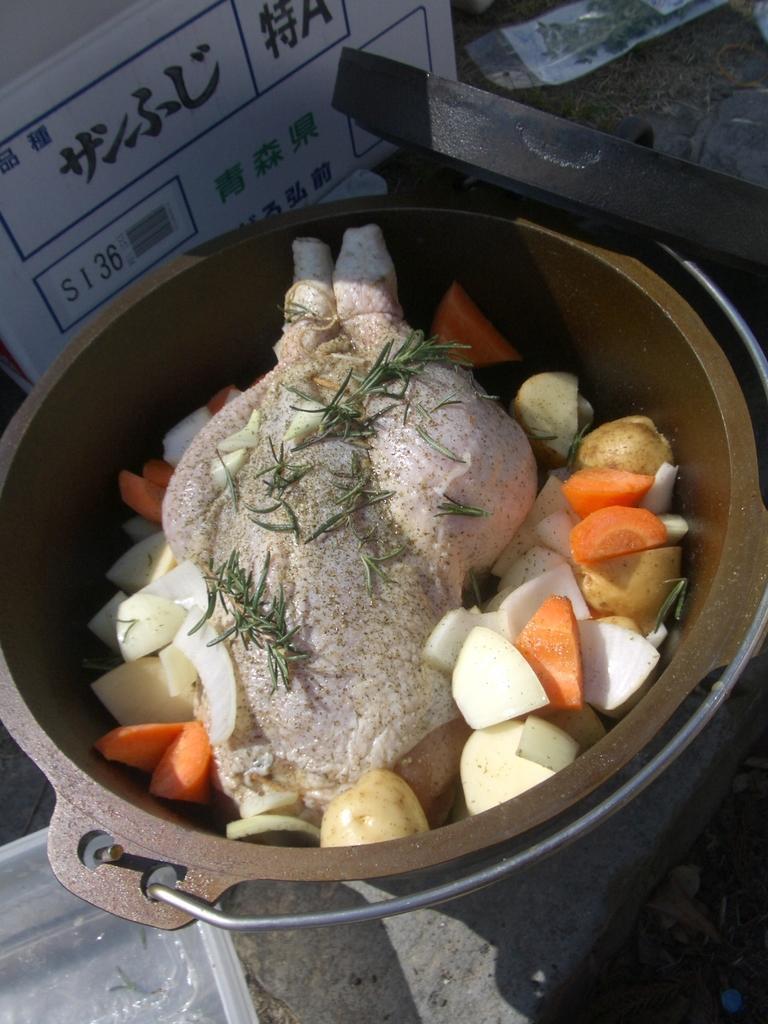Please provide a concise description of this image. In this image, we can see a vessel contains cut vegetables and chicken. There is a board at the top of the image. There is an object in the top right of the image. 